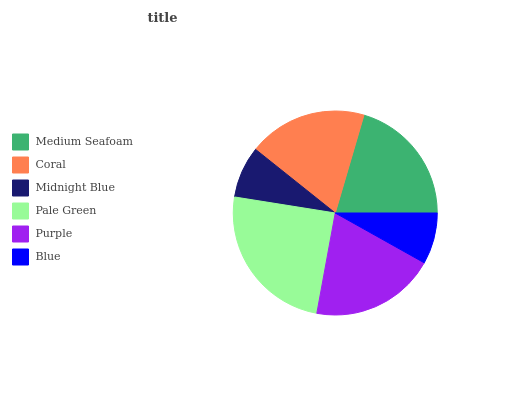Is Blue the minimum?
Answer yes or no. Yes. Is Pale Green the maximum?
Answer yes or no. Yes. Is Coral the minimum?
Answer yes or no. No. Is Coral the maximum?
Answer yes or no. No. Is Medium Seafoam greater than Coral?
Answer yes or no. Yes. Is Coral less than Medium Seafoam?
Answer yes or no. Yes. Is Coral greater than Medium Seafoam?
Answer yes or no. No. Is Medium Seafoam less than Coral?
Answer yes or no. No. Is Purple the high median?
Answer yes or no. Yes. Is Coral the low median?
Answer yes or no. Yes. Is Medium Seafoam the high median?
Answer yes or no. No. Is Medium Seafoam the low median?
Answer yes or no. No. 